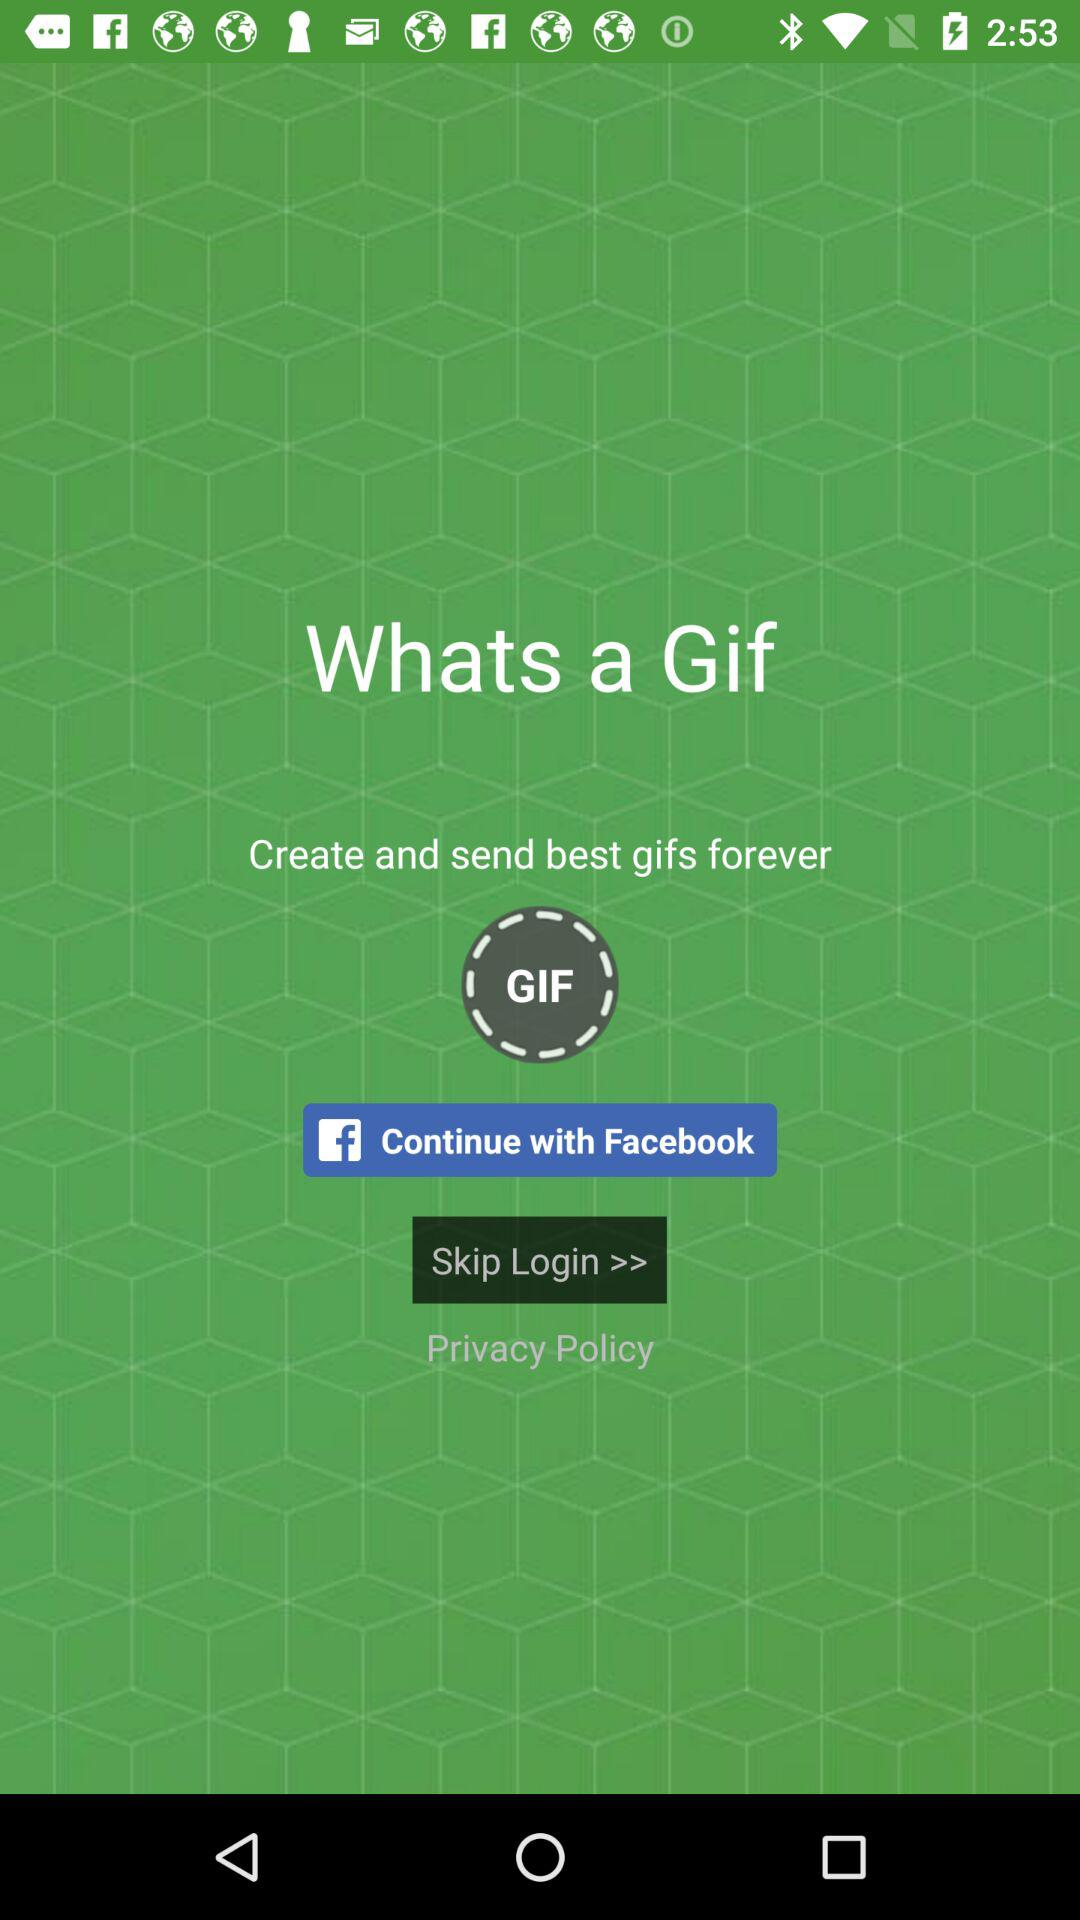What application can be used to continue? The application that can be used to continue is "Facebook". 